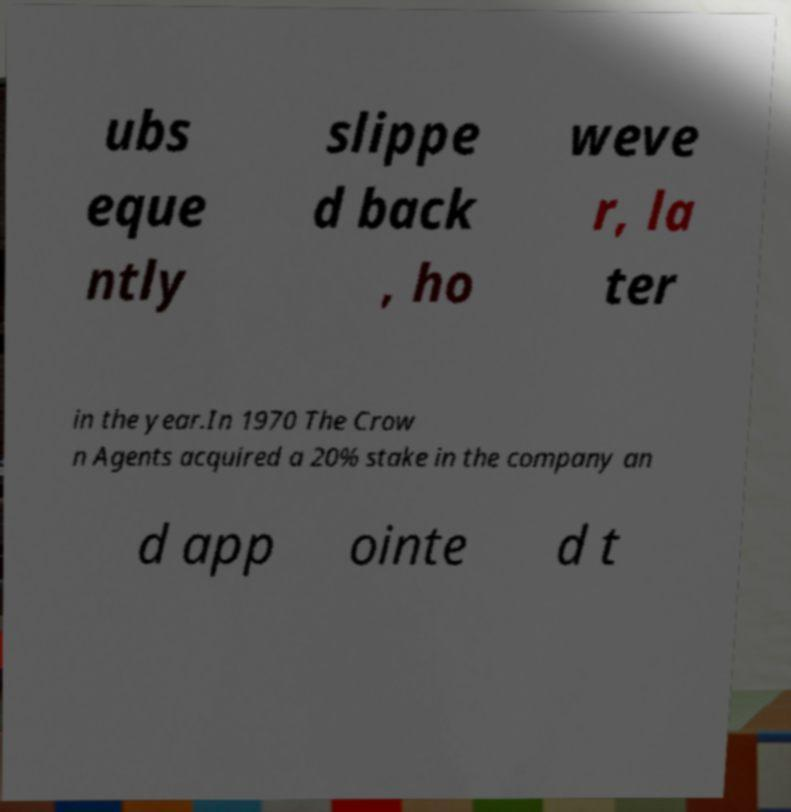Can you accurately transcribe the text from the provided image for me? ubs eque ntly slippe d back , ho weve r, la ter in the year.In 1970 The Crow n Agents acquired a 20% stake in the company an d app ointe d t 